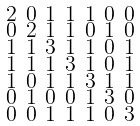<formula> <loc_0><loc_0><loc_500><loc_500>\begin{smallmatrix} 2 & 0 & 1 & 1 & 1 & 0 & 0 \\ 0 & 2 & 1 & 1 & 0 & 1 & 0 \\ 1 & 1 & 3 & 1 & 1 & 0 & 1 \\ 1 & 1 & 1 & 3 & 1 & 0 & 1 \\ 1 & 0 & 1 & 1 & 3 & 1 & 1 \\ 0 & 1 & 0 & 0 & 1 & 3 & 0 \\ 0 & 0 & 1 & 1 & 1 & 0 & 3 \end{smallmatrix}</formula> 